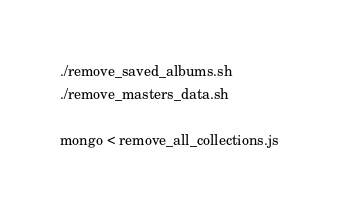Convert code to text. <code><loc_0><loc_0><loc_500><loc_500><_Bash_>./remove_saved_albums.sh
./remove_masters_data.sh

mongo < remove_all_collections.js
</code> 